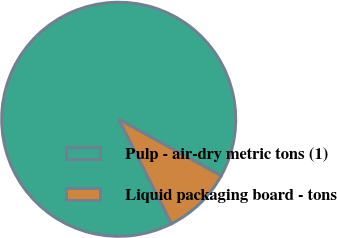<chart> <loc_0><loc_0><loc_500><loc_500><pie_chart><fcel>Pulp - air-dry metric tons (1)<fcel>Liquid packaging board - tons<nl><fcel>90.46%<fcel>9.54%<nl></chart> 